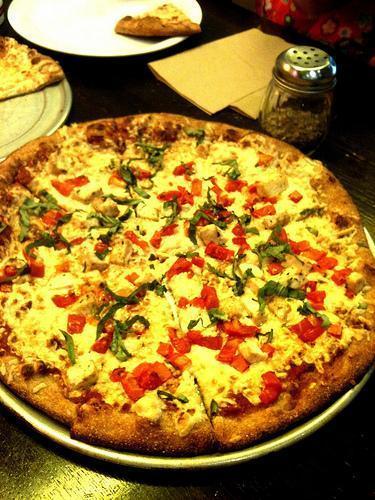How many slices on the white plate?
Give a very brief answer. 1. 